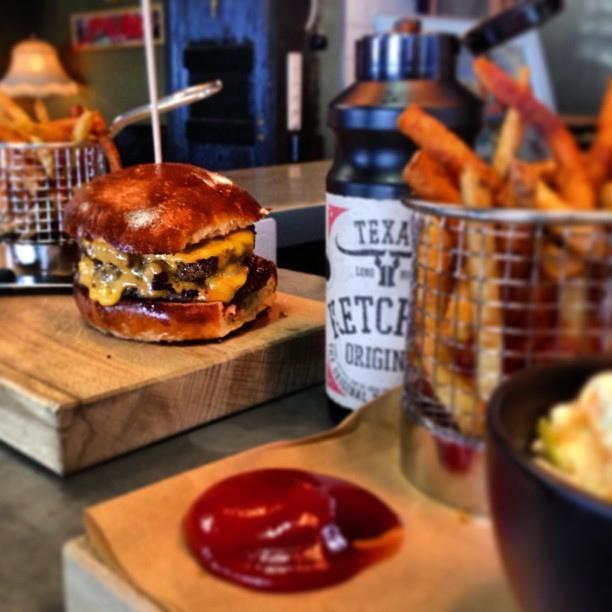Why is there a stick stuck in the cheeseburger? Please explain your reasoning. hold together. There is a cheeseburger in the picture with a large toothpick going through it.  some restaurants do this for the reason of holding entire burger together. 